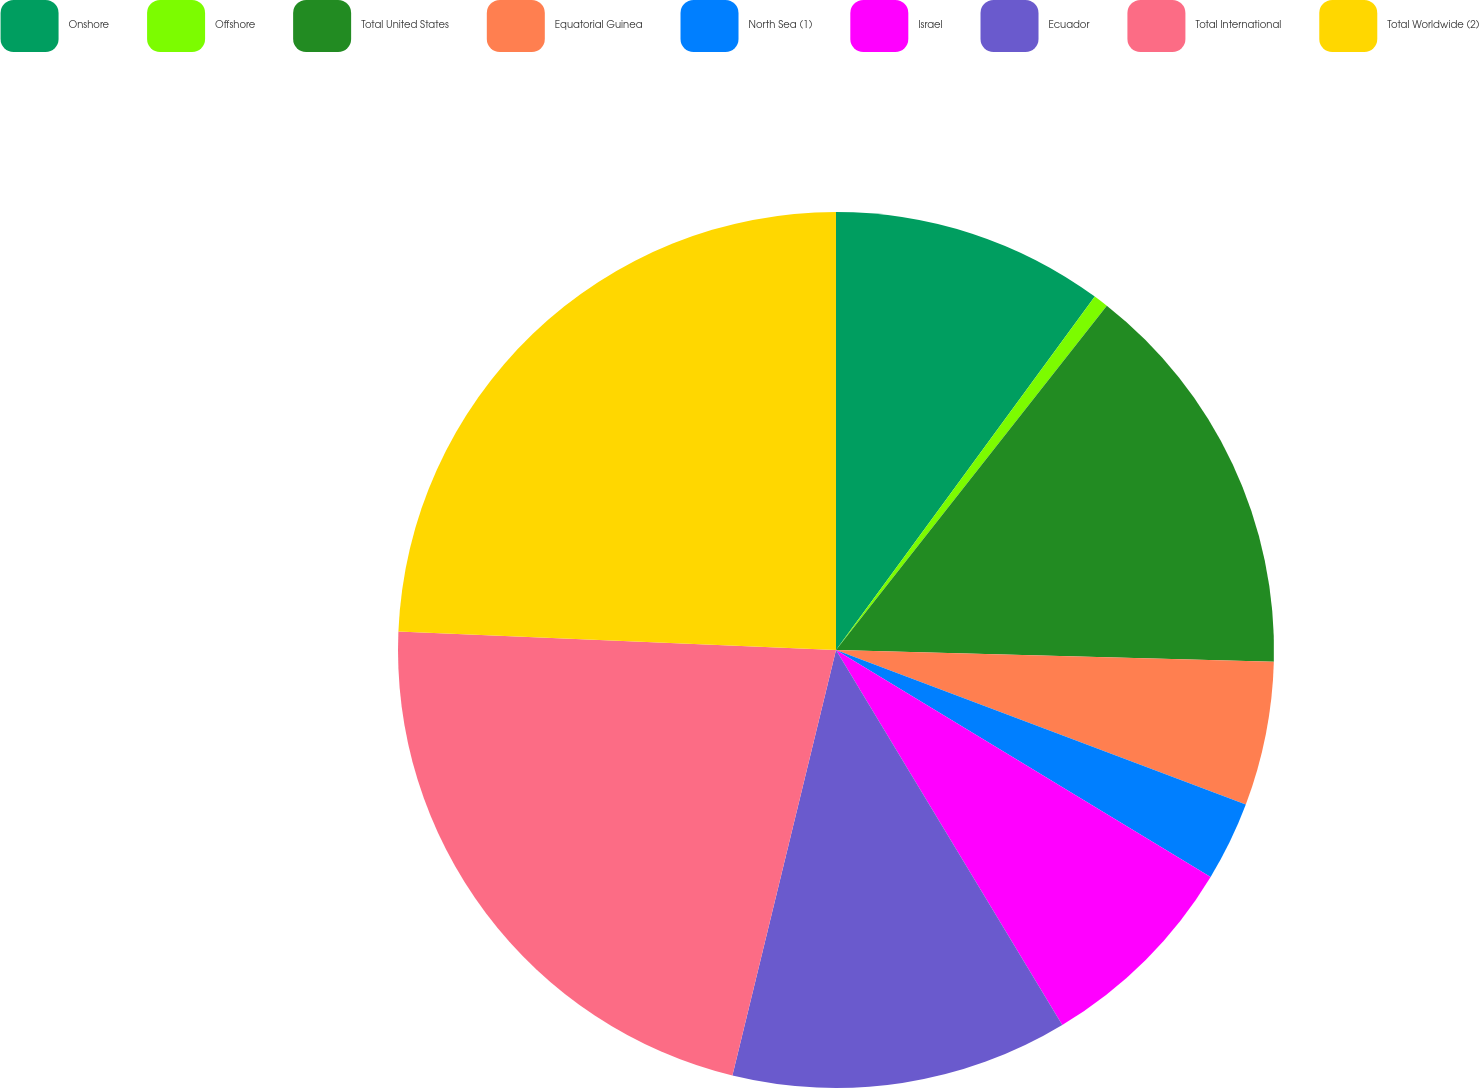<chart> <loc_0><loc_0><loc_500><loc_500><pie_chart><fcel>Onshore<fcel>Offshore<fcel>Total United States<fcel>Equatorial Guinea<fcel>North Sea (1)<fcel>Israel<fcel>Ecuador<fcel>Total International<fcel>Total Worldwide (2)<nl><fcel>10.06%<fcel>0.55%<fcel>14.82%<fcel>5.31%<fcel>2.93%<fcel>7.69%<fcel>12.44%<fcel>21.87%<fcel>24.33%<nl></chart> 